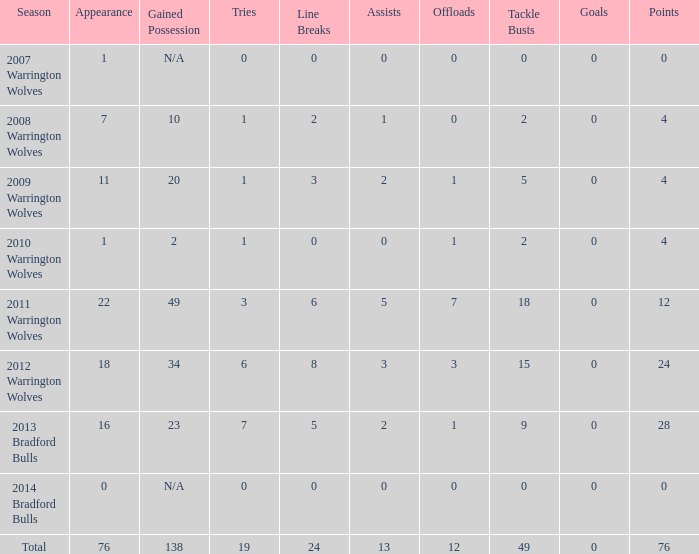What is the lowest appearance when goals is more than 0? None. 